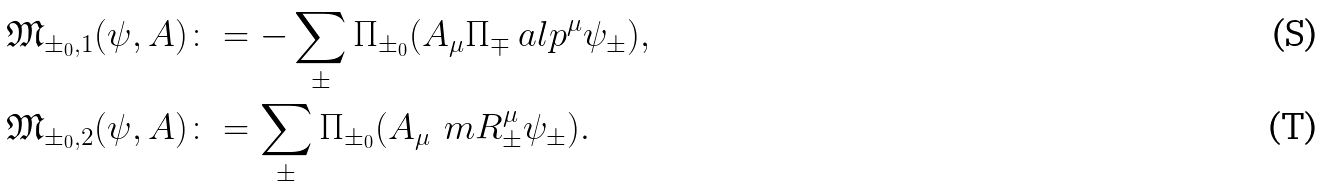<formula> <loc_0><loc_0><loc_500><loc_500>& \mathfrak { M } _ { \pm _ { 0 } , 1 } ( \psi , A ) \colon = - \sum _ { \pm } \Pi _ { \pm _ { 0 } } ( A _ { \mu } \Pi _ { \mp } \ a l p ^ { \mu } \psi _ { \pm } ) , \\ & \mathfrak { M } _ { \pm _ { 0 } , 2 } ( \psi , A ) \colon = \sum _ { \pm } \Pi _ { \pm _ { 0 } } ( A _ { \mu } \, \ m R ^ { \mu } _ { \pm } \psi _ { \pm } ) .</formula> 